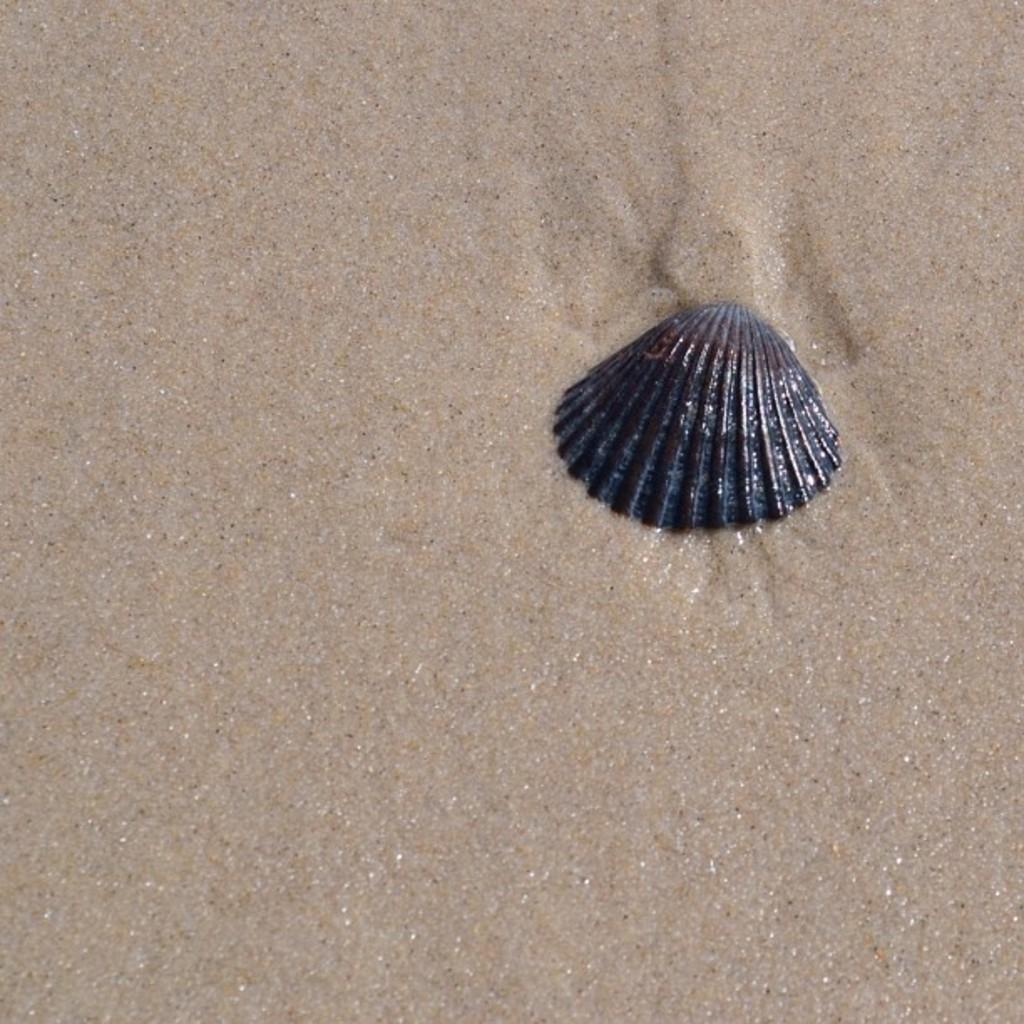What is the color of the shell in the image? The shell in the image is black. How does the icicle affect the current in the image? There is no icicle present in the image, so it cannot affect any current. 